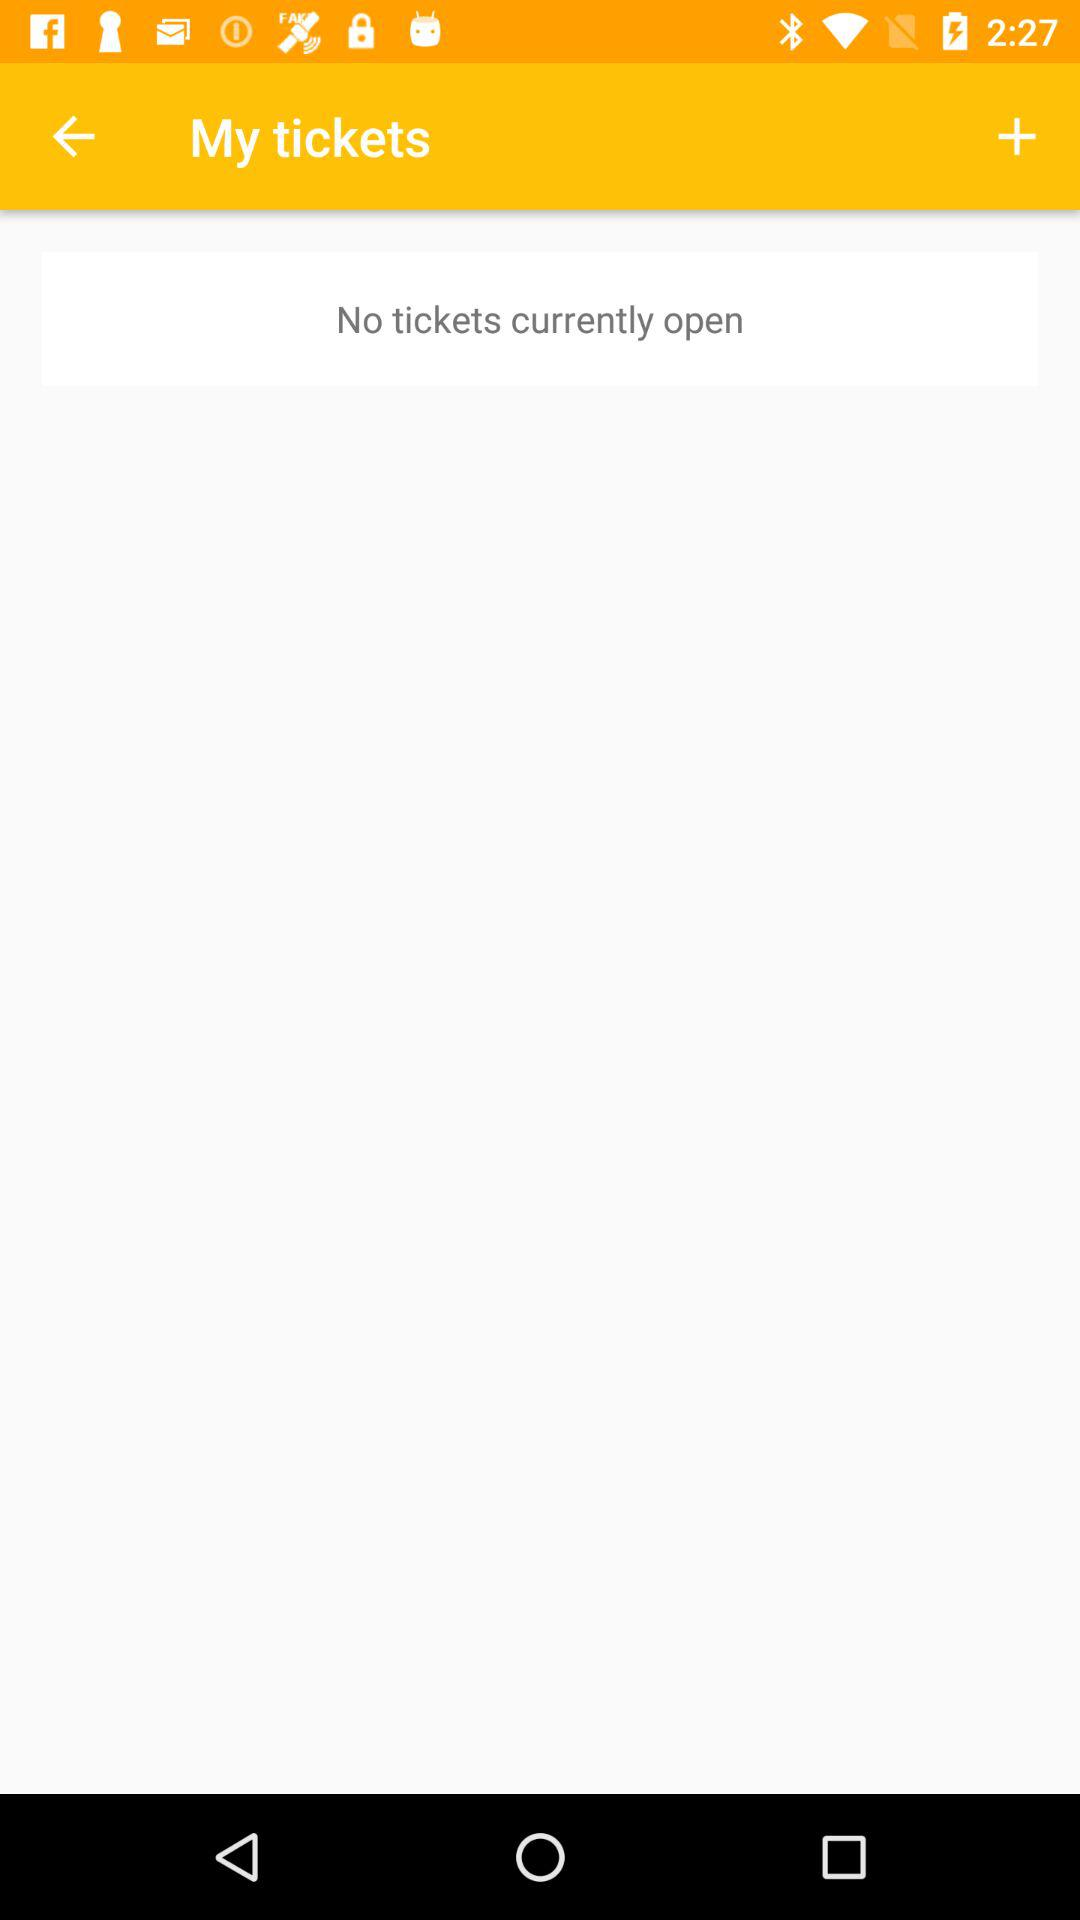Is there any open ticket? There is no open ticket. 